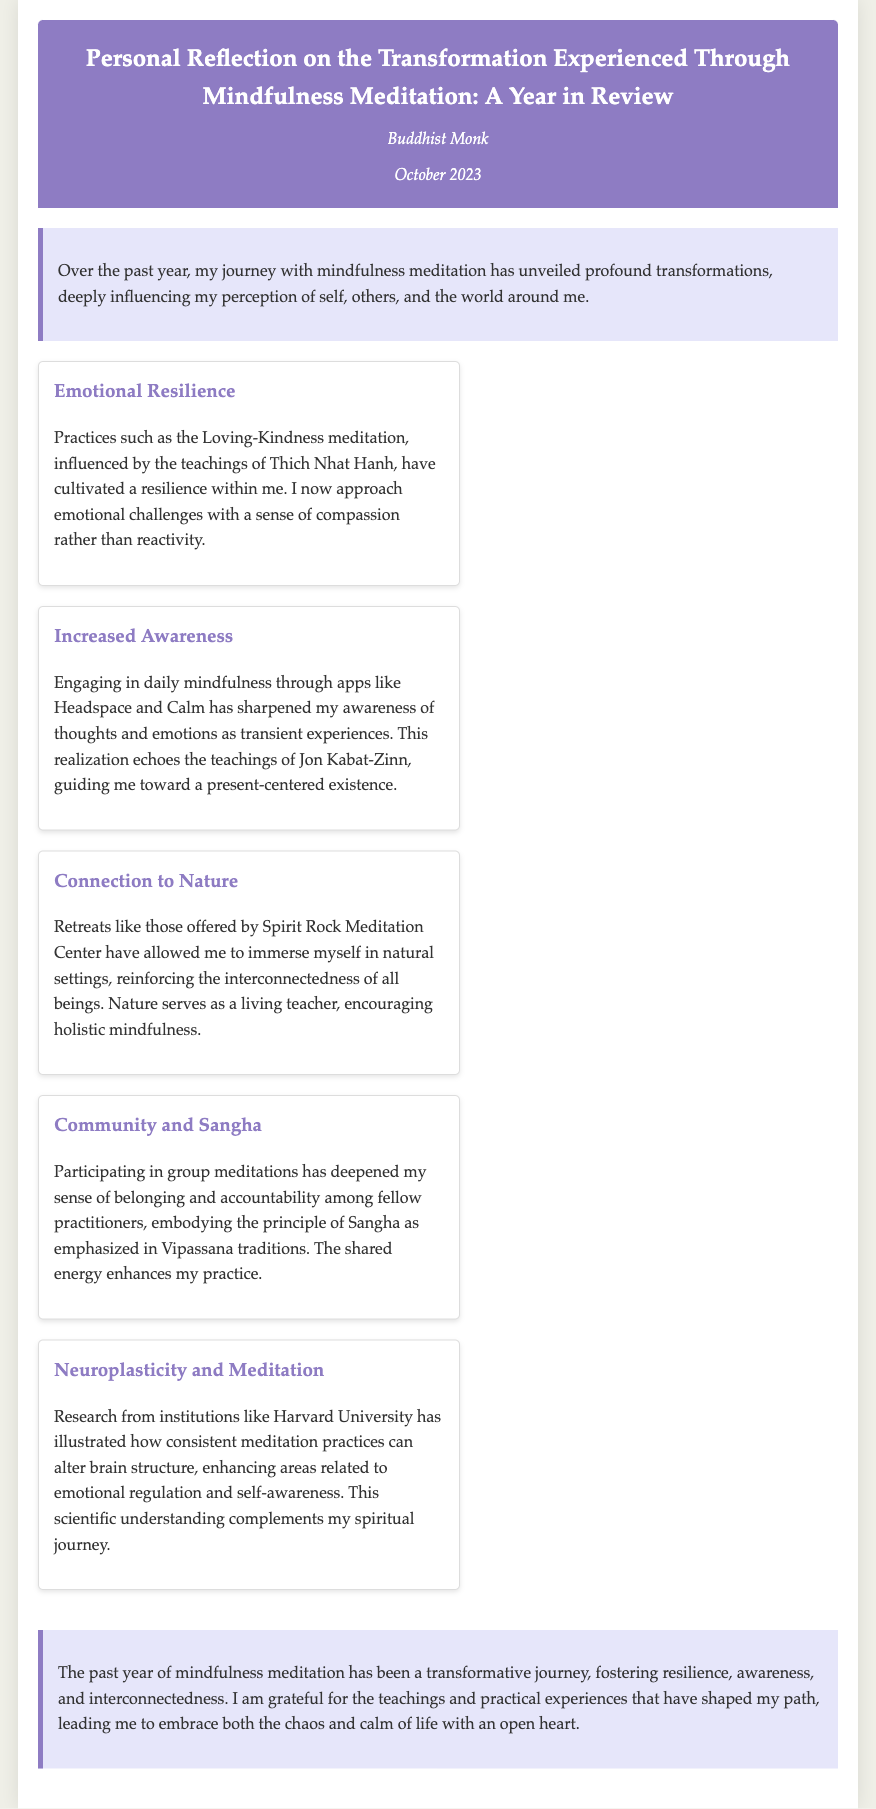What is the main topic of the reflection? The main topic discusses the transformation experienced through mindfulness meditation.
Answer: Mindfulness meditation Who is the author of the document? The document attributes the reflection to a Buddhist monk.
Answer: Buddhist Monk What meditation practice has cultivated resilience? The reflection mentions Loving-Kindness meditation as a practice that has cultivated resilience.
Answer: Loving-Kindness meditation Which meditation apps were used for daily mindfulness? The reflection lists Headspace and Calm as the apps utilized for daily mindfulness practices.
Answer: Headspace and Calm What has deepened the author's sense of belonging? Participating in group meditations has deepened the author's sense of belonging.
Answer: Group meditations What is the scientific institution mentioned in relation to neuroplasticity? The document references Harvard University regarding research on meditation's effects on brain structure.
Answer: Harvard University What does nature encourage according to the reflection? Nature serves as a living teacher, encouraging holistic mindfulness.
Answer: Holistic mindfulness What principle is emphasized in Vipassana traditions? The principle of Sangha is emphasized in Vipassana traditions as per the document.
Answer: Sangha 